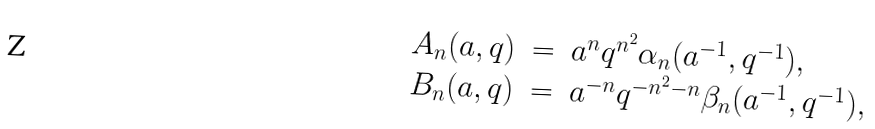<formula> <loc_0><loc_0><loc_500><loc_500>\begin{array} { r c l } A _ { n } ( a , q ) & = & a ^ { n } q ^ { n ^ { 2 } } \alpha _ { n } ( a ^ { - 1 } , q ^ { - 1 } ) , \\ B _ { n } ( a , q ) & = & a ^ { - n } q ^ { - n ^ { 2 } - n } \beta _ { n } ( a ^ { - 1 } , q ^ { - 1 } ) , \\ \end{array}</formula> 